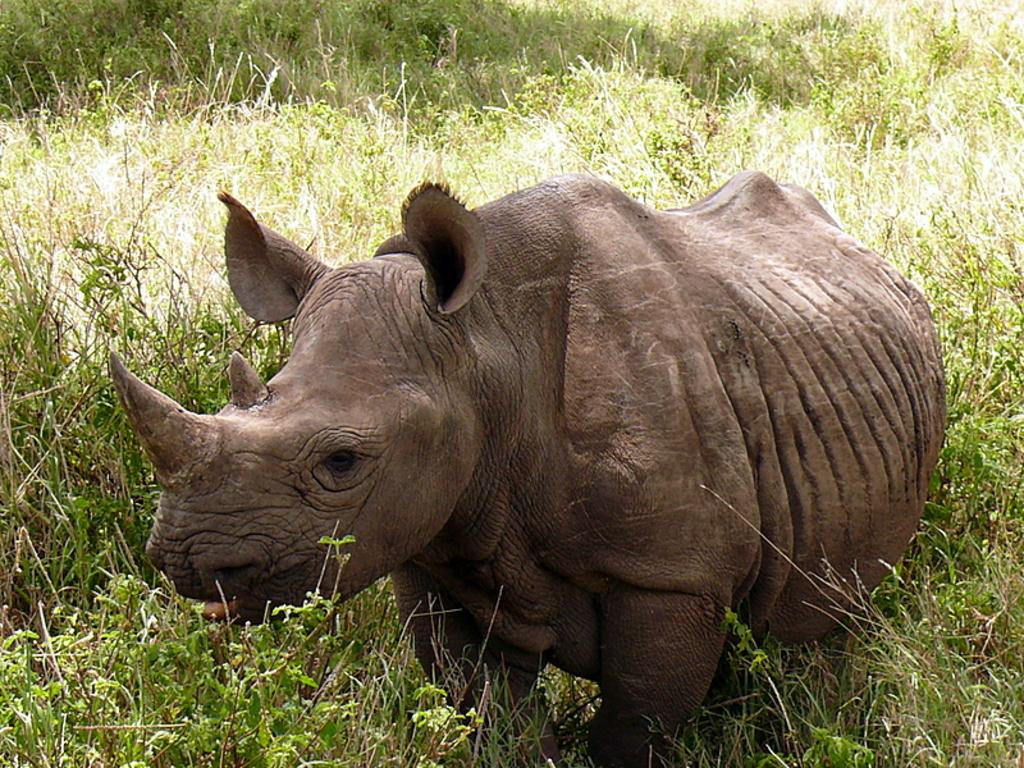What animal is present in the image? There is a rhinoceros in the image. Where is the rhinoceros located? The rhinoceros is on the ground. What can be seen in the background of the image? There are plants visible in the background of the image. What type of corn can be seen growing near the rhinoceros in the image? There is no corn present in the image; it only features a rhinoceros and plants in the background. 